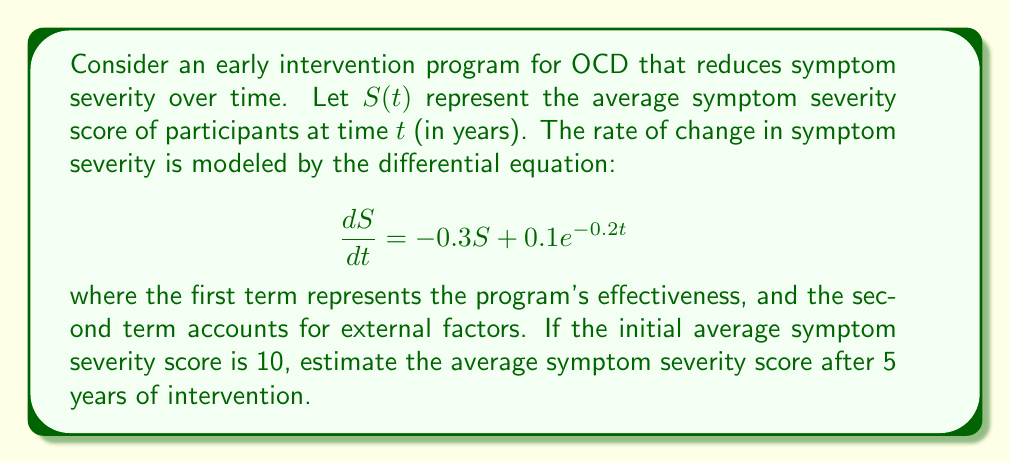Teach me how to tackle this problem. To solve this problem, we need to follow these steps:

1) The given differential equation is a first-order linear differential equation:

   $$\frac{dS}{dt} + 0.3S = 0.1e^{-0.2t}$$

2) The integrating factor is $e^{\int 0.3 dt} = e^{0.3t}$

3) Multiplying both sides by the integrating factor:

   $$e^{0.3t}\frac{dS}{dt} + 0.3e^{0.3t}S = 0.1e^{0.1t}$$

4) The left side is now the derivative of $e^{0.3t}S$:

   $$\frac{d}{dt}(e^{0.3t}S) = 0.1e^{0.1t}$$

5) Integrating both sides:

   $$e^{0.3t}S = 0.1\int e^{0.1t}dt + C = 0.1 \cdot \frac{1}{0.1}e^{0.1t} + C = e^{0.1t} + C$$

6) Solving for S:

   $$S = e^{-0.2t} + Ce^{-0.3t}$$

7) Using the initial condition $S(0) = 10$:

   $$10 = 1 + C \implies C = 9$$

8) Therefore, the general solution is:

   $$S(t) = e^{-0.2t} + 9e^{-0.3t}$$

9) To find S(5), we substitute t = 5:

   $$S(5) = e^{-0.2(5)} + 9e^{-0.3(5)} = e^{-1} + 9e^{-1.5}$$

10) Calculating this value:

    $$S(5) \approx 0.3679 + 2.0031 \approx 2.3710$$
Answer: 2.3710 